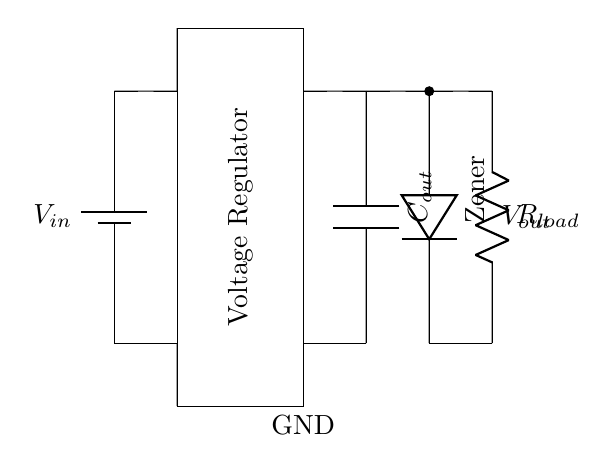What is the input voltage in the circuit? The input voltage is provided from the battery, labeled as V_in in the diagram.
Answer: V_in What is the function of the voltage regulator? The voltage regulator serves to maintain a constant output voltage (V_out) regardless of changes in input voltage or load conditions.
Answer: To maintain constant output voltage Which component protects against overvoltage? The Zener diode is the component that protects the circuit from overvoltage conditions by shunting excess voltage when it exceeds its breakdown voltage.
Answer: Zener diode What type of load is connected to the output? The load connected to the output is indicated as R_load, which typically represents a resistor in the circuit.
Answer: Resistor What is the role of the output capacitor? The output capacitor (C_out) smooths out the output voltage, reducing voltage fluctuations and providing stability to the load.
Answer: Smoothing output voltage How many main components are in this circuit? The main components include the battery, voltage regulator, output capacitor, Zener diode, and load resistor, totaling five primary components.
Answer: Five components What happens when the voltage exceeds the Zener voltage? When the voltage exceeds the Zener voltage, the Zener diode enters reverse breakdown, allowing current to flow through it and thereby protecting the load from excessive voltage.
Answer: Current flows through Zener diode 